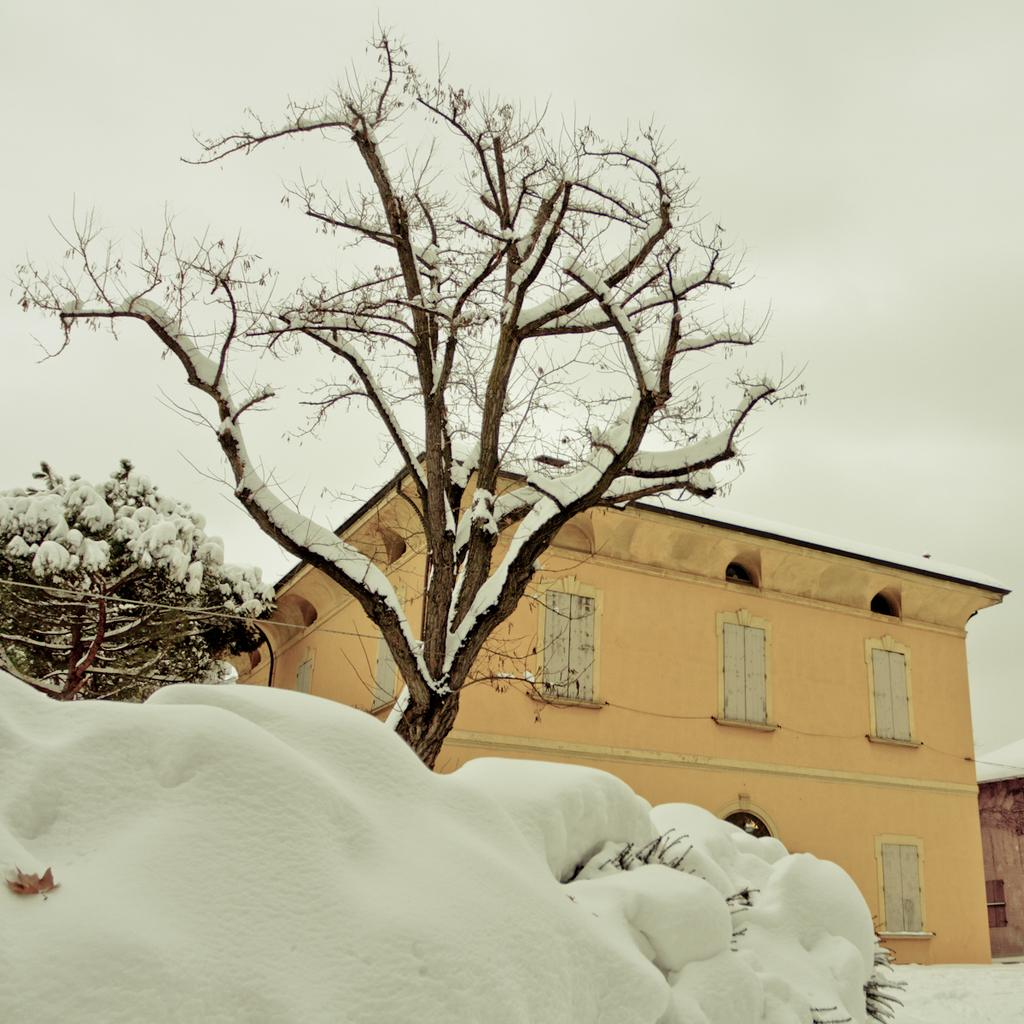What type of structure is present in the image? There is a house in the image. What feature of the house is mentioned in the facts? The house has windows. What other natural elements are present in the image? There are trees and snow visible in the image. What can be seen in the background of the image? The sky is visible in the background of the image. What is the interest rate for the mortgage on the house in the image? There is no information about a mortgage or interest rate in the image or the provided facts. 